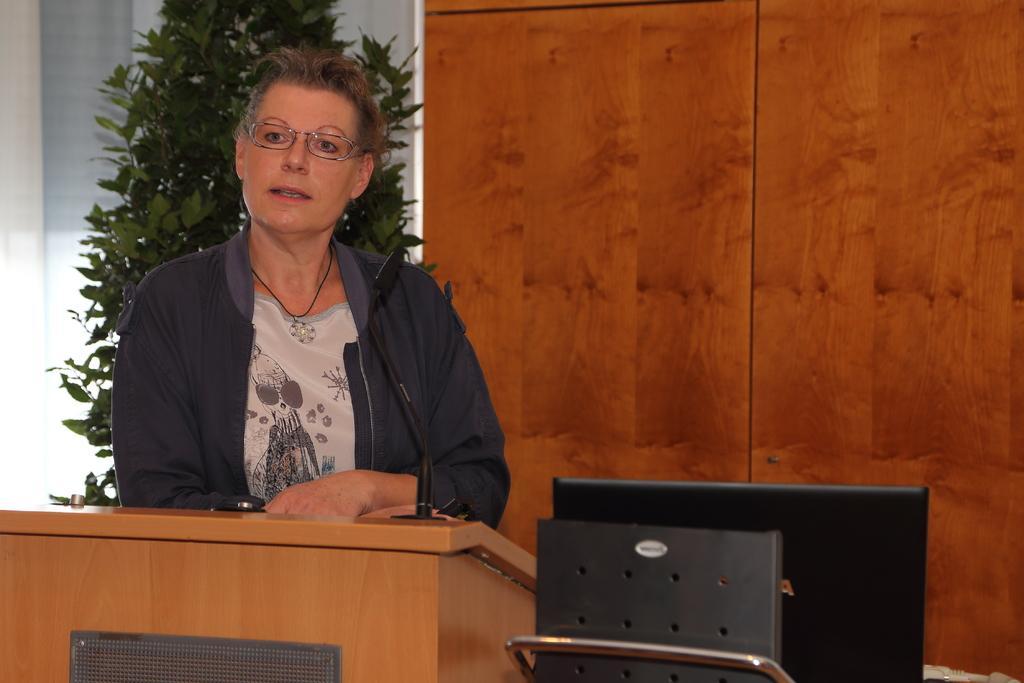Could you give a brief overview of what you see in this image? In this image a lady is standing behind a podium. in front of her there is a mic. She is wearing a jacket, t-shirt and glasses. In the right there is a laptop. In the background there is wall and plant. 